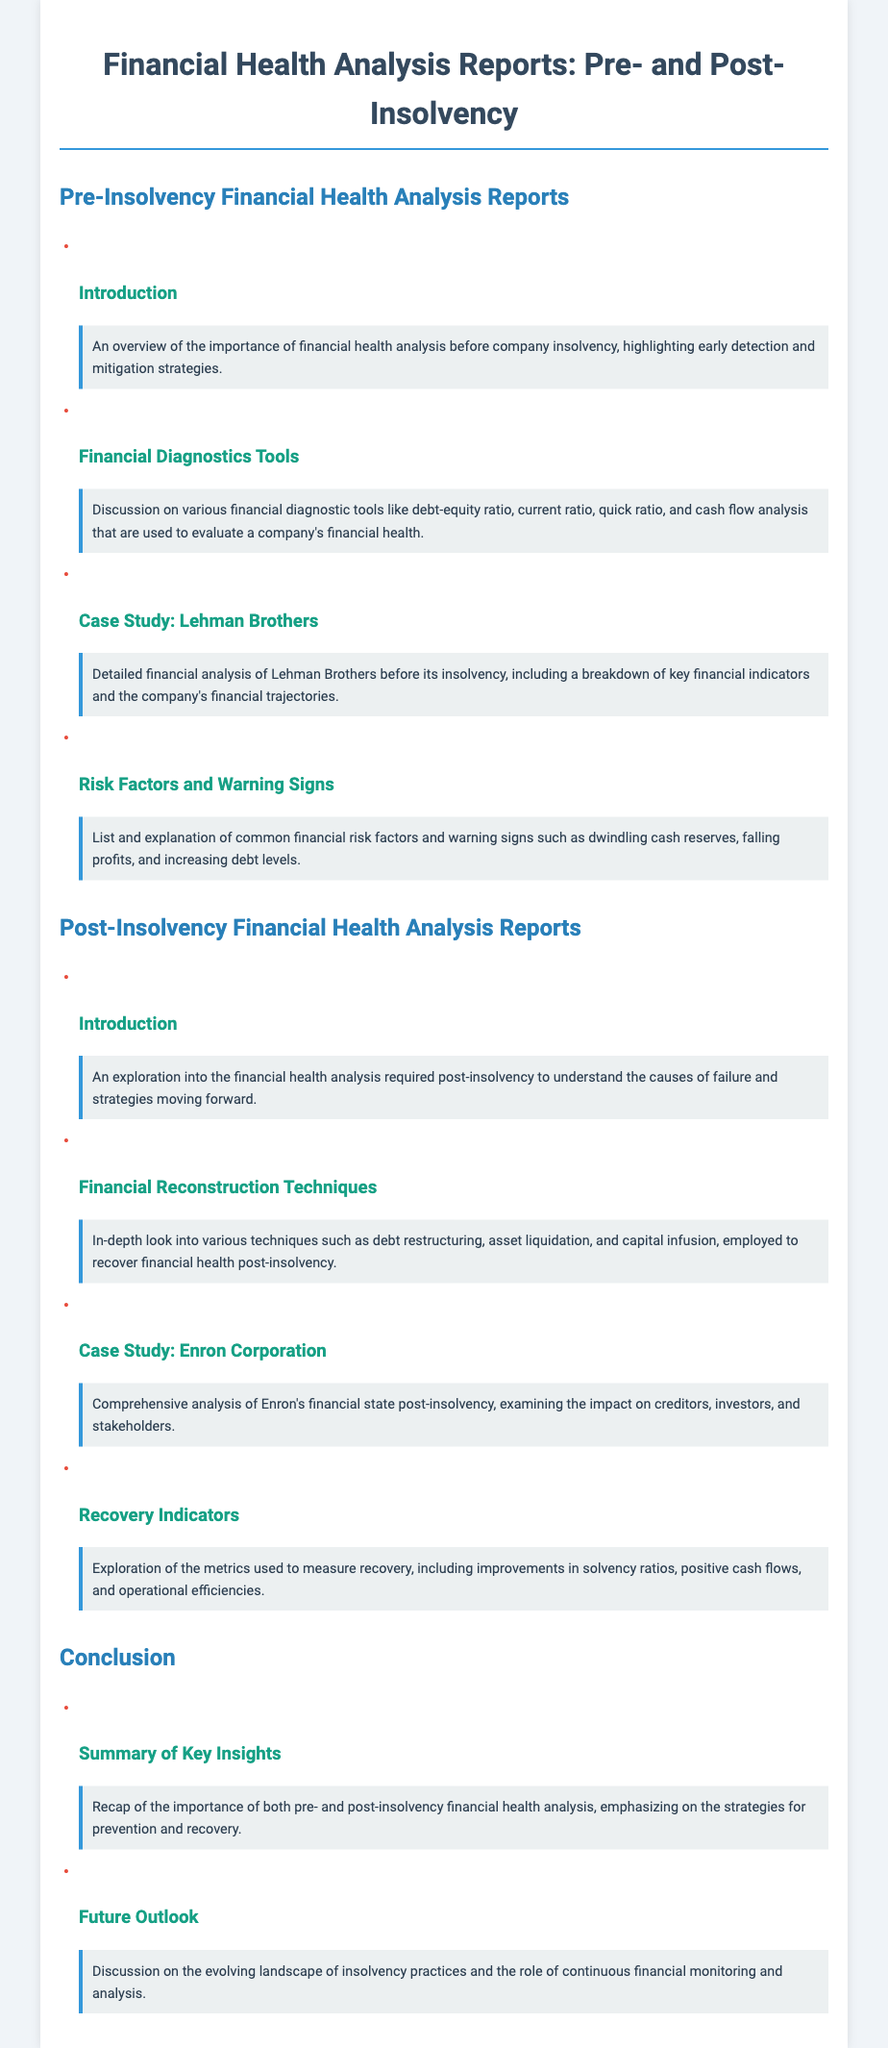What is the title of the document? The title is presented in the header of the document, which clearly states its purpose.
Answer: Financial Health Analysis Reports: Pre- and Post-Insolvency What is included in the Pre-Insolvency section? This section outlines various analyses that are crucial before a company faces insolvency.
Answer: Financial Health Analysis Reports Which notable case is discussed in the Pre-Insolvency analysis? This refers to a specific company that is used as an example for analysis in this section.
Answer: Lehman Brothers What technique is examined in the Post-Insolvency section? This allows insight into methods used for recovery after insolvency.
Answer: Debt restructuring What are Recovery Indicators? This concept refers to metrics that help assess improvements in financial health post-insolvency.
Answer: Metrics used to measure recovery What is emphasized in the Conclusion section? This section highlights key takeaways from the analyses discussed earlier in the document.
Answer: Importance of both pre- and post-insolvency financial health analysis What color is used for the subheadings in the document? This detail refers to the visual design choice made to differentiate headings.
Answer: The color is #2980b9 What company is used as a case study in the Post-Insolvency analysis? This question targets the specific example used for analyzing post-insolvency recovery.
Answer: Enron Corporation 